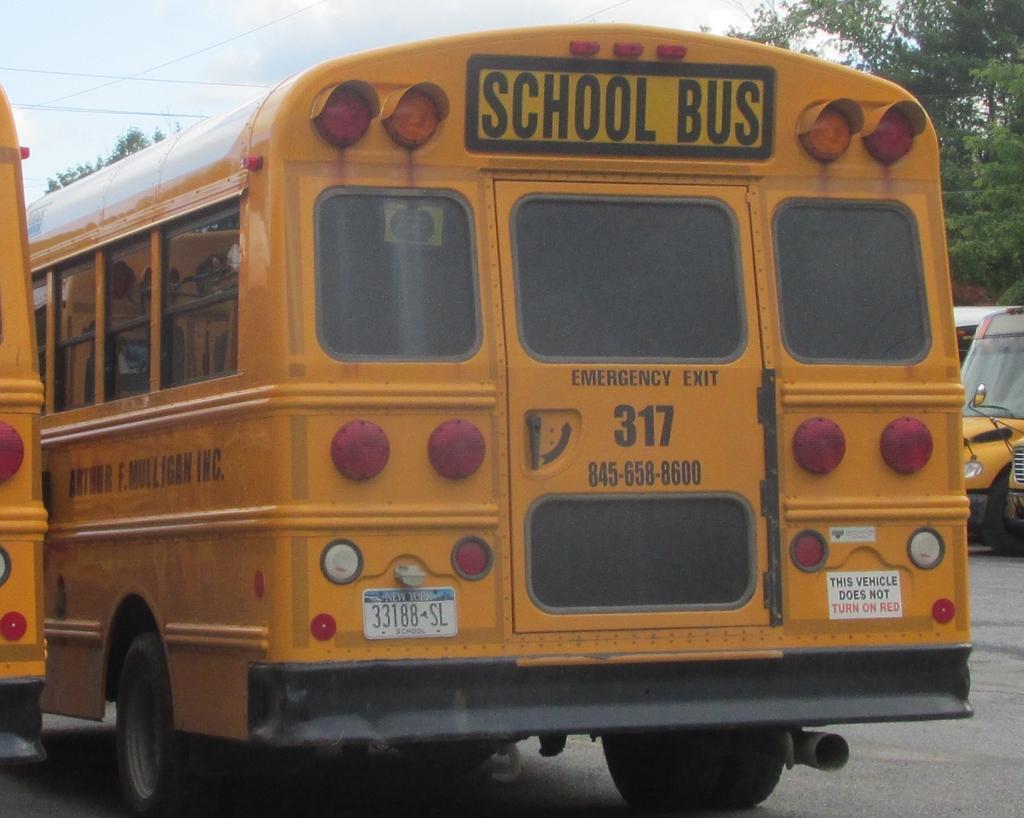Could you give a brief overview of what you see in this image? In the image there are school buses on the road the road, on the left side there are trees and above its sky with clouds. 